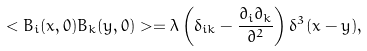Convert formula to latex. <formula><loc_0><loc_0><loc_500><loc_500>< B _ { i } ( { x } , 0 ) B _ { k } ( { y } , 0 ) > = \lambda \left ( \delta _ { i k } - \frac { \partial _ { i } \partial _ { k } } { \partial ^ { 2 } } \right ) \delta ^ { 3 } ( { x } - { y } ) ,</formula> 